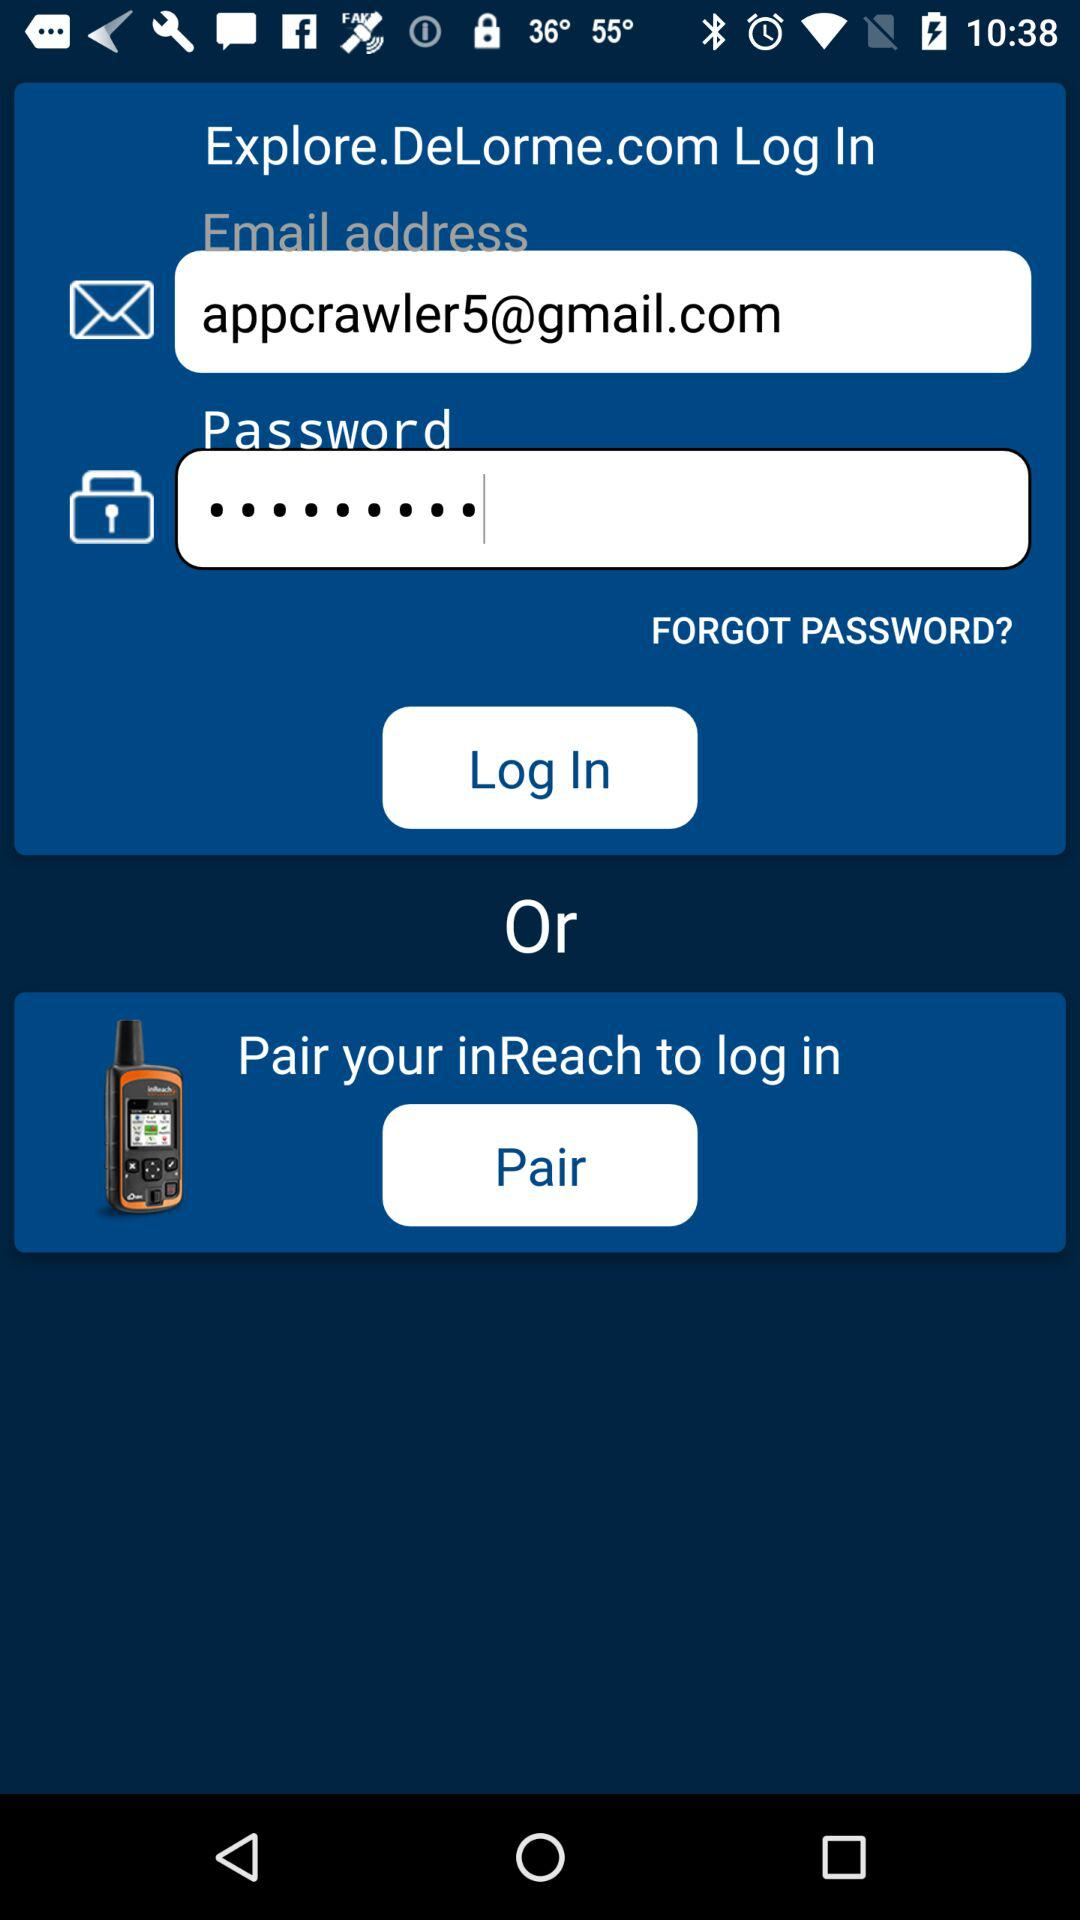What is the email address? The email address is appcrawler5@gmail.com. 